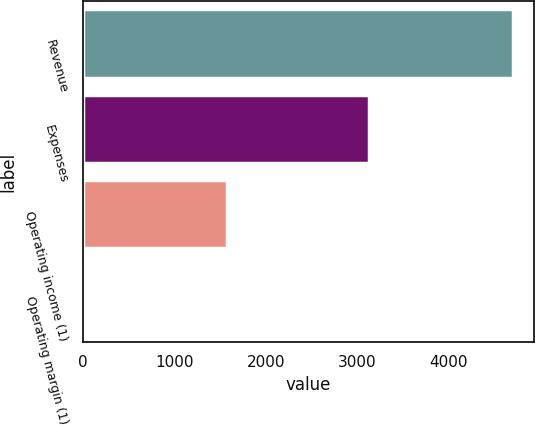Convert chart to OTSL. <chart><loc_0><loc_0><loc_500><loc_500><bar_chart><fcel>Revenue<fcel>Expenses<fcel>Operating income (1)<fcel>Operating margin (1)<nl><fcel>4700<fcel>3130<fcel>1570<fcel>38.2<nl></chart> 